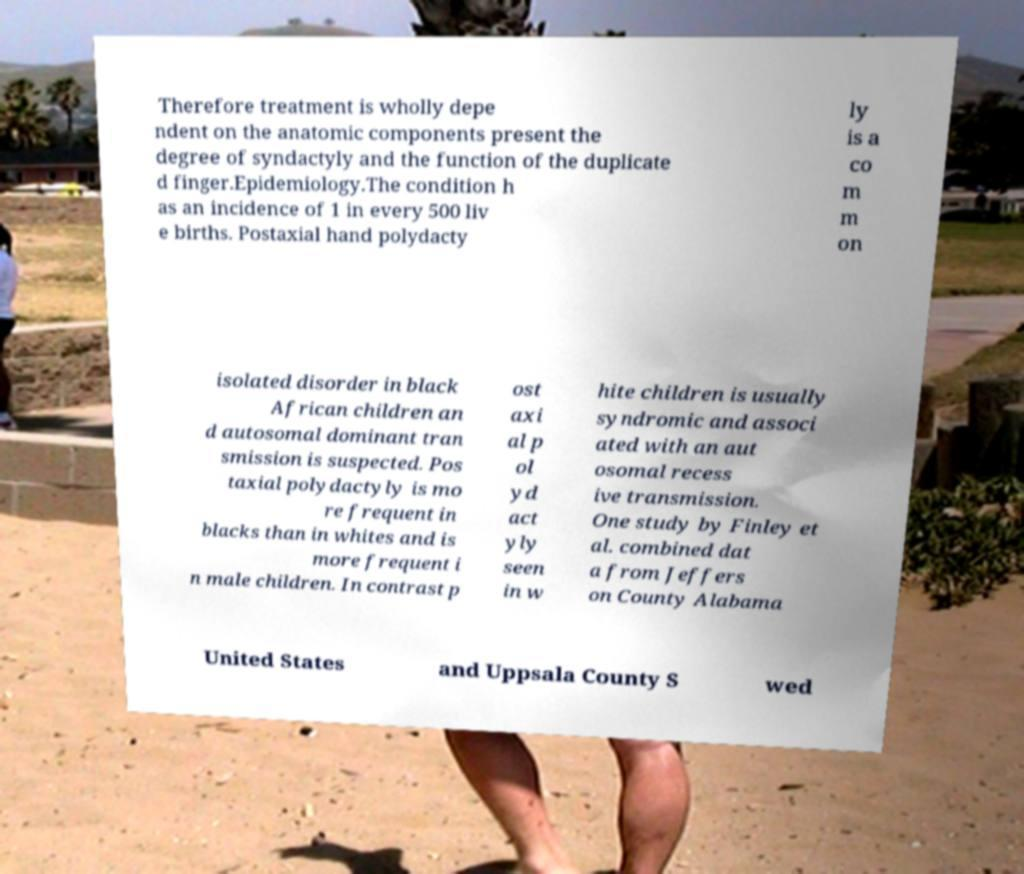Can you read and provide the text displayed in the image?This photo seems to have some interesting text. Can you extract and type it out for me? Therefore treatment is wholly depe ndent on the anatomic components present the degree of syndactyly and the function of the duplicate d finger.Epidemiology.The condition h as an incidence of 1 in every 500 liv e births. Postaxial hand polydacty ly is a co m m on isolated disorder in black African children an d autosomal dominant tran smission is suspected. Pos taxial polydactyly is mo re frequent in blacks than in whites and is more frequent i n male children. In contrast p ost axi al p ol yd act yly seen in w hite children is usually syndromic and associ ated with an aut osomal recess ive transmission. One study by Finley et al. combined dat a from Jeffers on County Alabama United States and Uppsala County S wed 